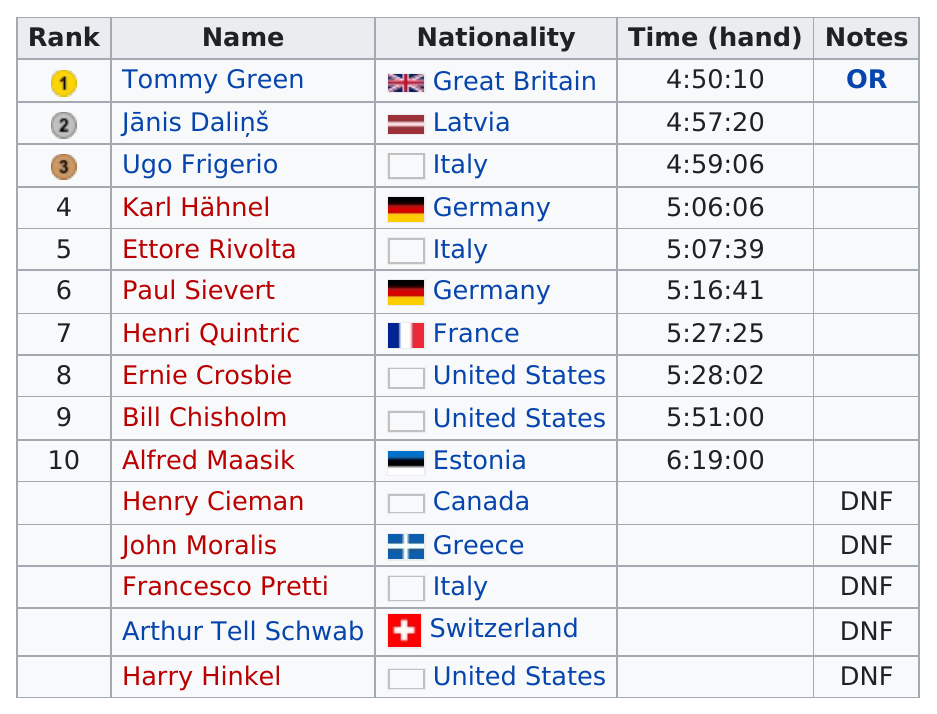Outline some significant characteristics in this image. There are 10 ranks in total. Karl Hahnel finished immediately after Ettore Rivolta, who was a competitor. Of the competitors who had times that were above five minutes but below six minutes, we found that there were six individuals who had this particular time. The combined time it took the first three competitors to finish the race was 14 hours, 46 minutes, and 36 seconds. The last competitor to actually finish the race was Alfred Maasik. 